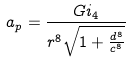<formula> <loc_0><loc_0><loc_500><loc_500>a _ { p } = \frac { G i _ { 4 } } { r ^ { 8 } \sqrt { 1 + \frac { d ^ { 8 } } { c ^ { 8 } } } }</formula> 